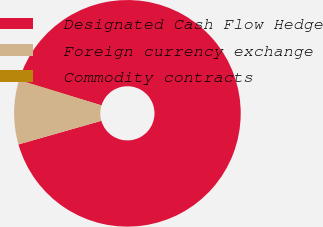<chart> <loc_0><loc_0><loc_500><loc_500><pie_chart><fcel>Designated Cash Flow Hedge<fcel>Foreign currency exchange<fcel>Commodity contracts<nl><fcel>90.83%<fcel>9.12%<fcel>0.05%<nl></chart> 